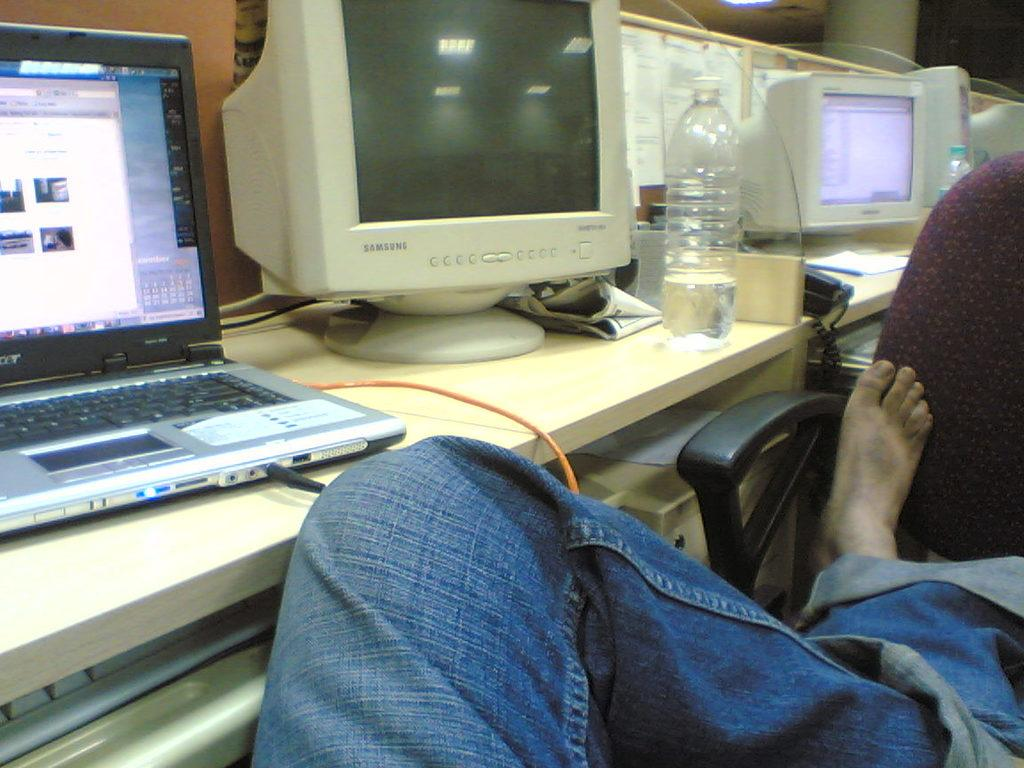What is placed on the chair in the image? There is a person's leg on a chair. What can be seen on the table in the image? There is a monitor, a bottle, posters, and a laptop on the table. What type of electronic device is on the table? There is a laptop on the table. What is the purpose of the posters on the table? The purpose of the posters is not specified in the image, but they may be for decoration or information. How many men are visible in the image? There is no information about men in the image; it only shows a person's leg on a chair and objects on a table. 